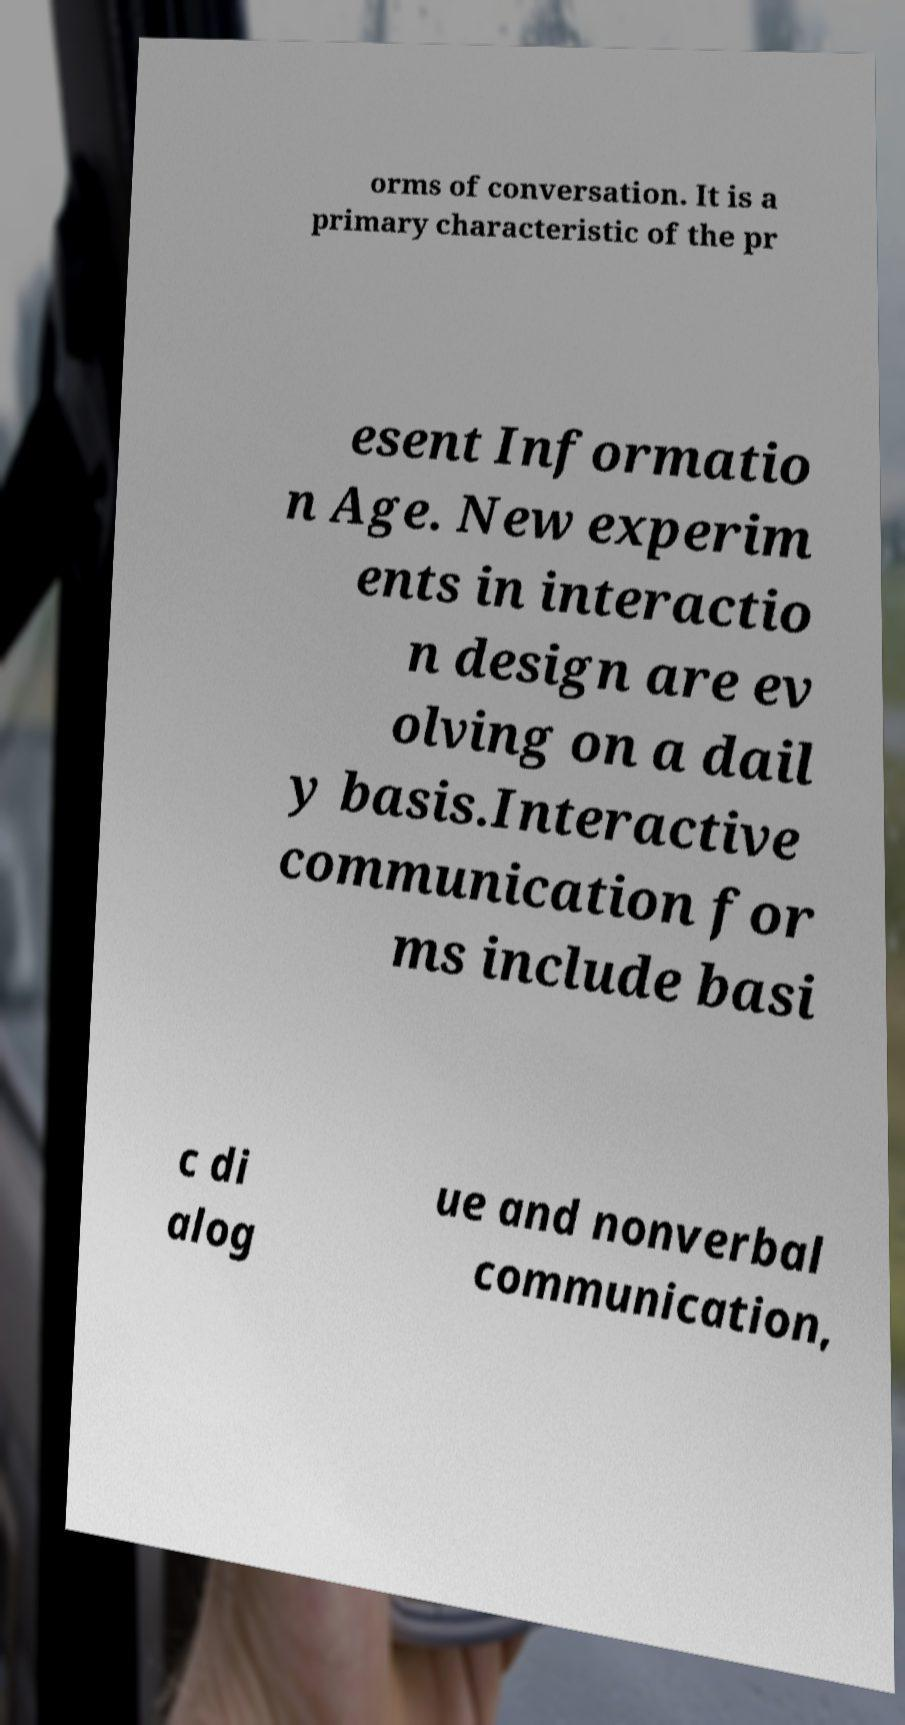For documentation purposes, I need the text within this image transcribed. Could you provide that? orms of conversation. It is a primary characteristic of the pr esent Informatio n Age. New experim ents in interactio n design are ev olving on a dail y basis.Interactive communication for ms include basi c di alog ue and nonverbal communication, 